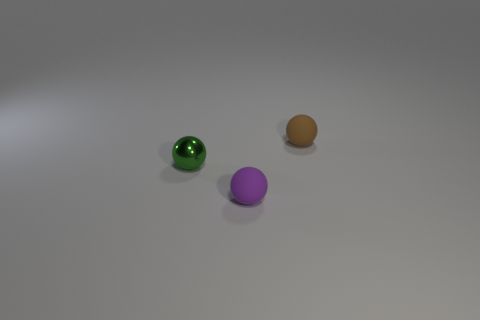Add 2 purple balls. How many objects exist? 5 Subtract 0 yellow spheres. How many objects are left? 3 Subtract all green spheres. Subtract all tiny red cylinders. How many objects are left? 2 Add 1 tiny brown objects. How many tiny brown objects are left? 2 Add 3 small brown things. How many small brown things exist? 4 